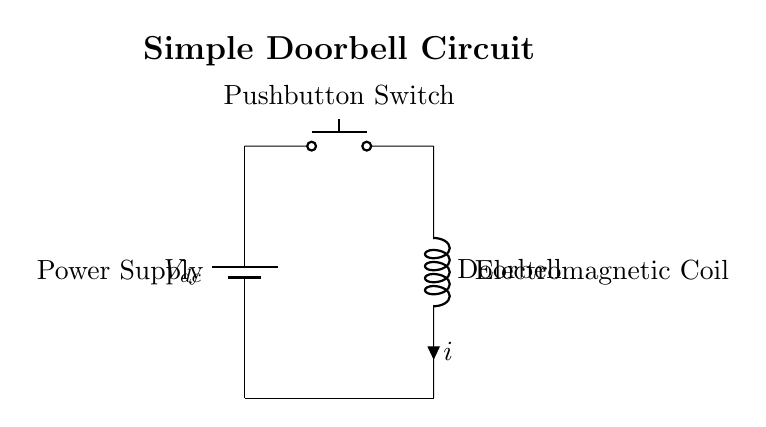What is the type of battery used in the circuit? The schematic shows a symbol for a battery labeled as Vdc, which indicates a direct current source. This suggests that the circuit uses a direct current battery.
Answer: direct current What is the function of the pushbutton switch in this circuit? The pushbutton switch is designed to open and close the circuit when pressed, allowing the current to flow only when it is engaged, thereby activating the doorbell.
Answer: connect/disconnect current How many main components are in the circuit? The circuit includes three main components: a battery, a pushbutton switch, and an electromagnetic coil.
Answer: three What happens to the current when the pushbutton switch is pressed? When the pushbutton switch is pressed, it closes the circuit, which allows current to flow through the electromagnetic coil, activating the doorbell.
Answer: current flows What indicates that this circuit operates with an electromagnetic principle? The presence of the inductor labeled as "Doorbell" shows that it uses electromagnetic coils, which operate on magnetic principles when current flows, generating a magnetic field that activates the bell.
Answer: inductor What is the primary purpose of the electromagnetic coil in the circuit? The electromagnetic coil, labeled as "Doorbell," serves to convert electrical energy into mechanical energy to produce sound or movement when the circuit is completed.
Answer: sound generation 